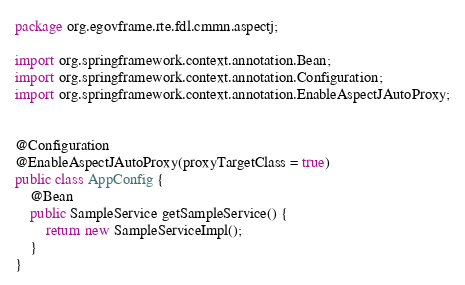<code> <loc_0><loc_0><loc_500><loc_500><_Java_>package org.egovframe.rte.fdl.cmmn.aspectj;

import org.springframework.context.annotation.Bean;
import org.springframework.context.annotation.Configuration;
import org.springframework.context.annotation.EnableAspectJAutoProxy;


@Configuration
@EnableAspectJAutoProxy(proxyTargetClass = true)
public class AppConfig {
	@Bean
	public SampleService getSampleService() {
		return new SampleServiceImpl();
	}
}
</code> 